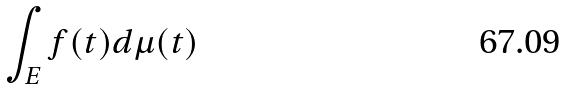<formula> <loc_0><loc_0><loc_500><loc_500>\int _ { E } f ( t ) d \mu ( t )</formula> 